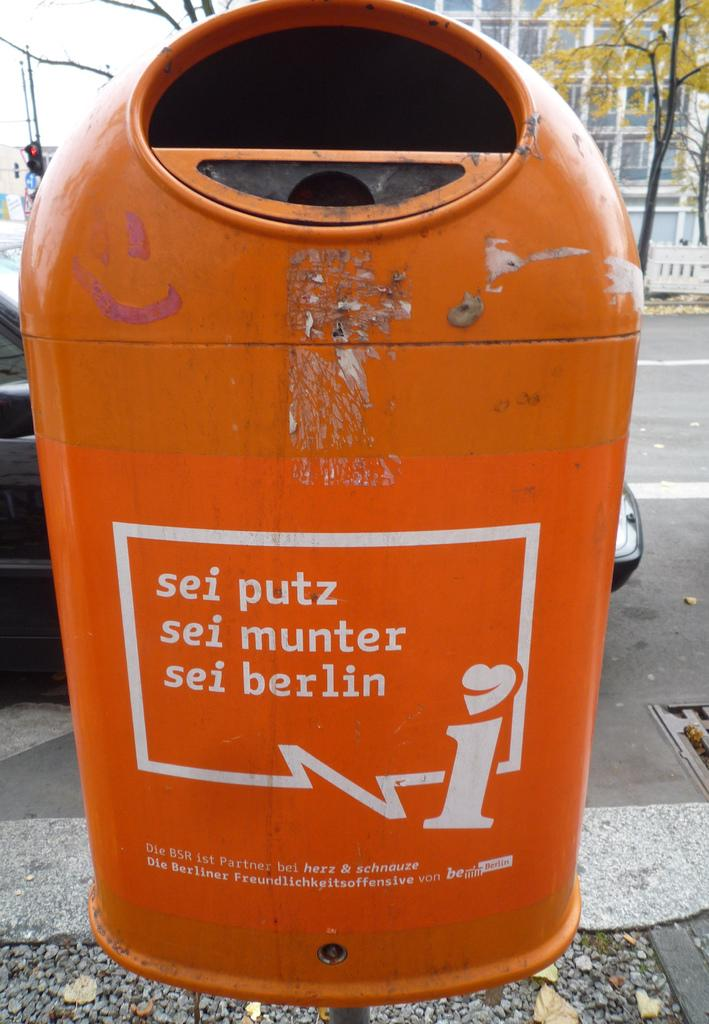<image>
Relay a brief, clear account of the picture shown. An orange trash can is advertising a message from Berlin. 